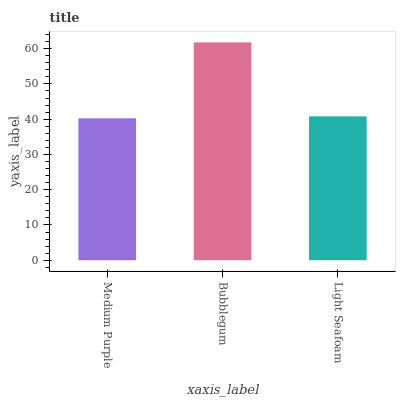Is Light Seafoam the minimum?
Answer yes or no. No. Is Light Seafoam the maximum?
Answer yes or no. No. Is Bubblegum greater than Light Seafoam?
Answer yes or no. Yes. Is Light Seafoam less than Bubblegum?
Answer yes or no. Yes. Is Light Seafoam greater than Bubblegum?
Answer yes or no. No. Is Bubblegum less than Light Seafoam?
Answer yes or no. No. Is Light Seafoam the high median?
Answer yes or no. Yes. Is Light Seafoam the low median?
Answer yes or no. Yes. Is Bubblegum the high median?
Answer yes or no. No. Is Bubblegum the low median?
Answer yes or no. No. 